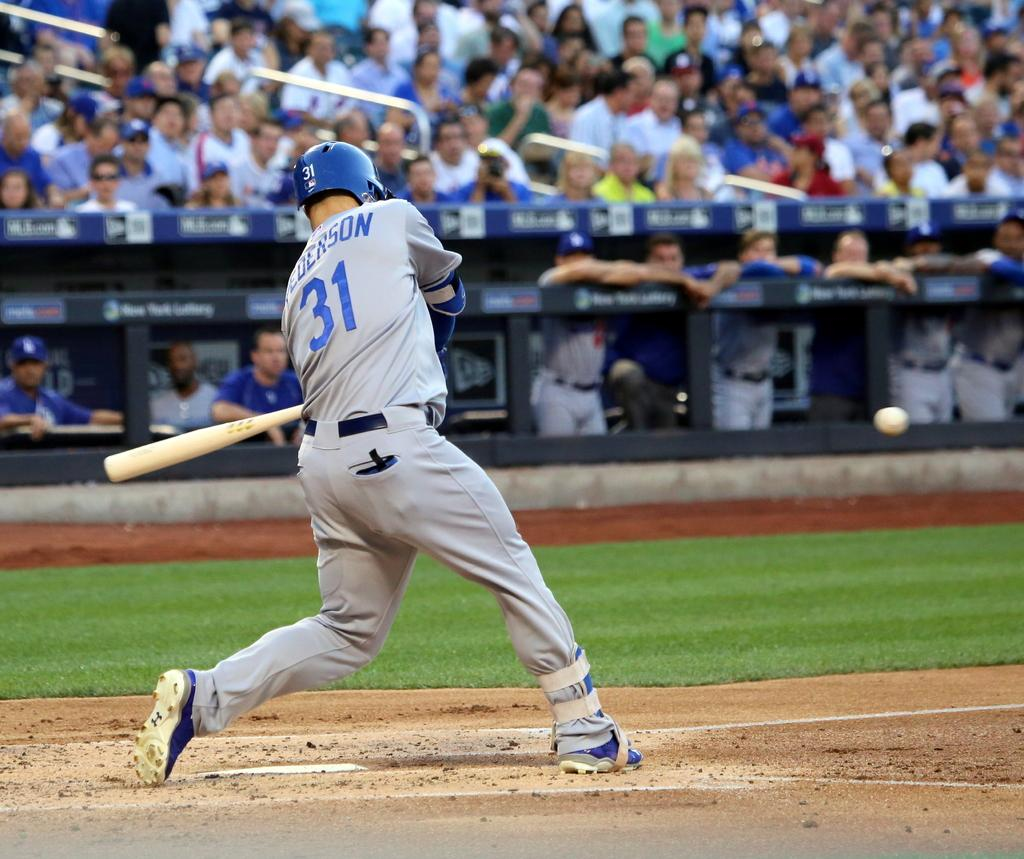<image>
Provide a brief description of the given image. A baseball player wearing a blue helmet and number 31 just hit the ball. 